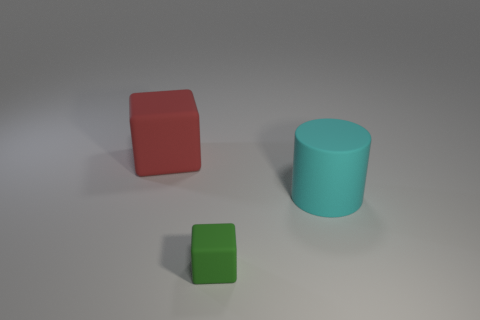What number of blue metallic cylinders are there?
Your response must be concise. 0. There is a cyan cylinder; does it have the same size as the rubber block that is in front of the large red thing?
Make the answer very short. No. What material is the small block in front of the big rubber thing that is behind the big cyan rubber thing?
Give a very brief answer. Rubber. There is a rubber cube behind the block that is to the right of the block behind the green block; how big is it?
Give a very brief answer. Large. There is a small green thing; is its shape the same as the large matte thing to the left of the tiny green matte object?
Offer a very short reply. Yes. What is the material of the cyan object?
Give a very brief answer. Rubber. How many metallic things are small things or tiny cyan cylinders?
Offer a terse response. 0. Is the number of green cubes that are on the left side of the big red object less than the number of small green matte objects behind the green object?
Your response must be concise. No. There is a matte cube in front of the cube on the left side of the tiny rubber thing; are there any small green matte things that are in front of it?
Provide a succinct answer. No. Do the large thing that is to the left of the big cylinder and the object that is in front of the large cyan matte cylinder have the same shape?
Ensure brevity in your answer.  Yes. 